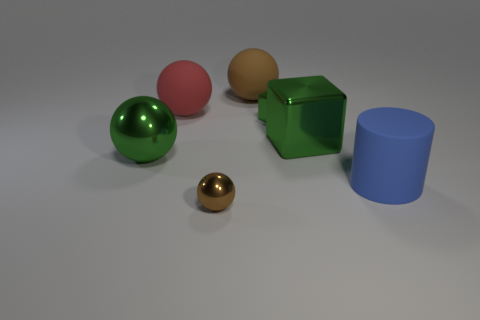If we were to categorize these objects by size, how would we group them? In terms of size, we could categorize the objects into two groups: the large objects and the small object. The large objects include the green sphere, pink sphere, green cube, and the blue cylinder, while the small object is the brown sphere. 